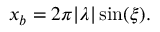<formula> <loc_0><loc_0><loc_500><loc_500>\begin{array} { r } { x _ { b } = 2 \pi | \lambda | \sin ( \xi ) . } \end{array}</formula> 